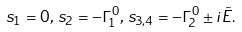Convert formula to latex. <formula><loc_0><loc_0><loc_500><loc_500>s _ { 1 } = 0 , \, s _ { 2 } = - \Gamma _ { 1 } ^ { 0 } , \, s _ { 3 , 4 } = - \Gamma _ { 2 } ^ { 0 } \pm i { \tilde { E } } .</formula> 